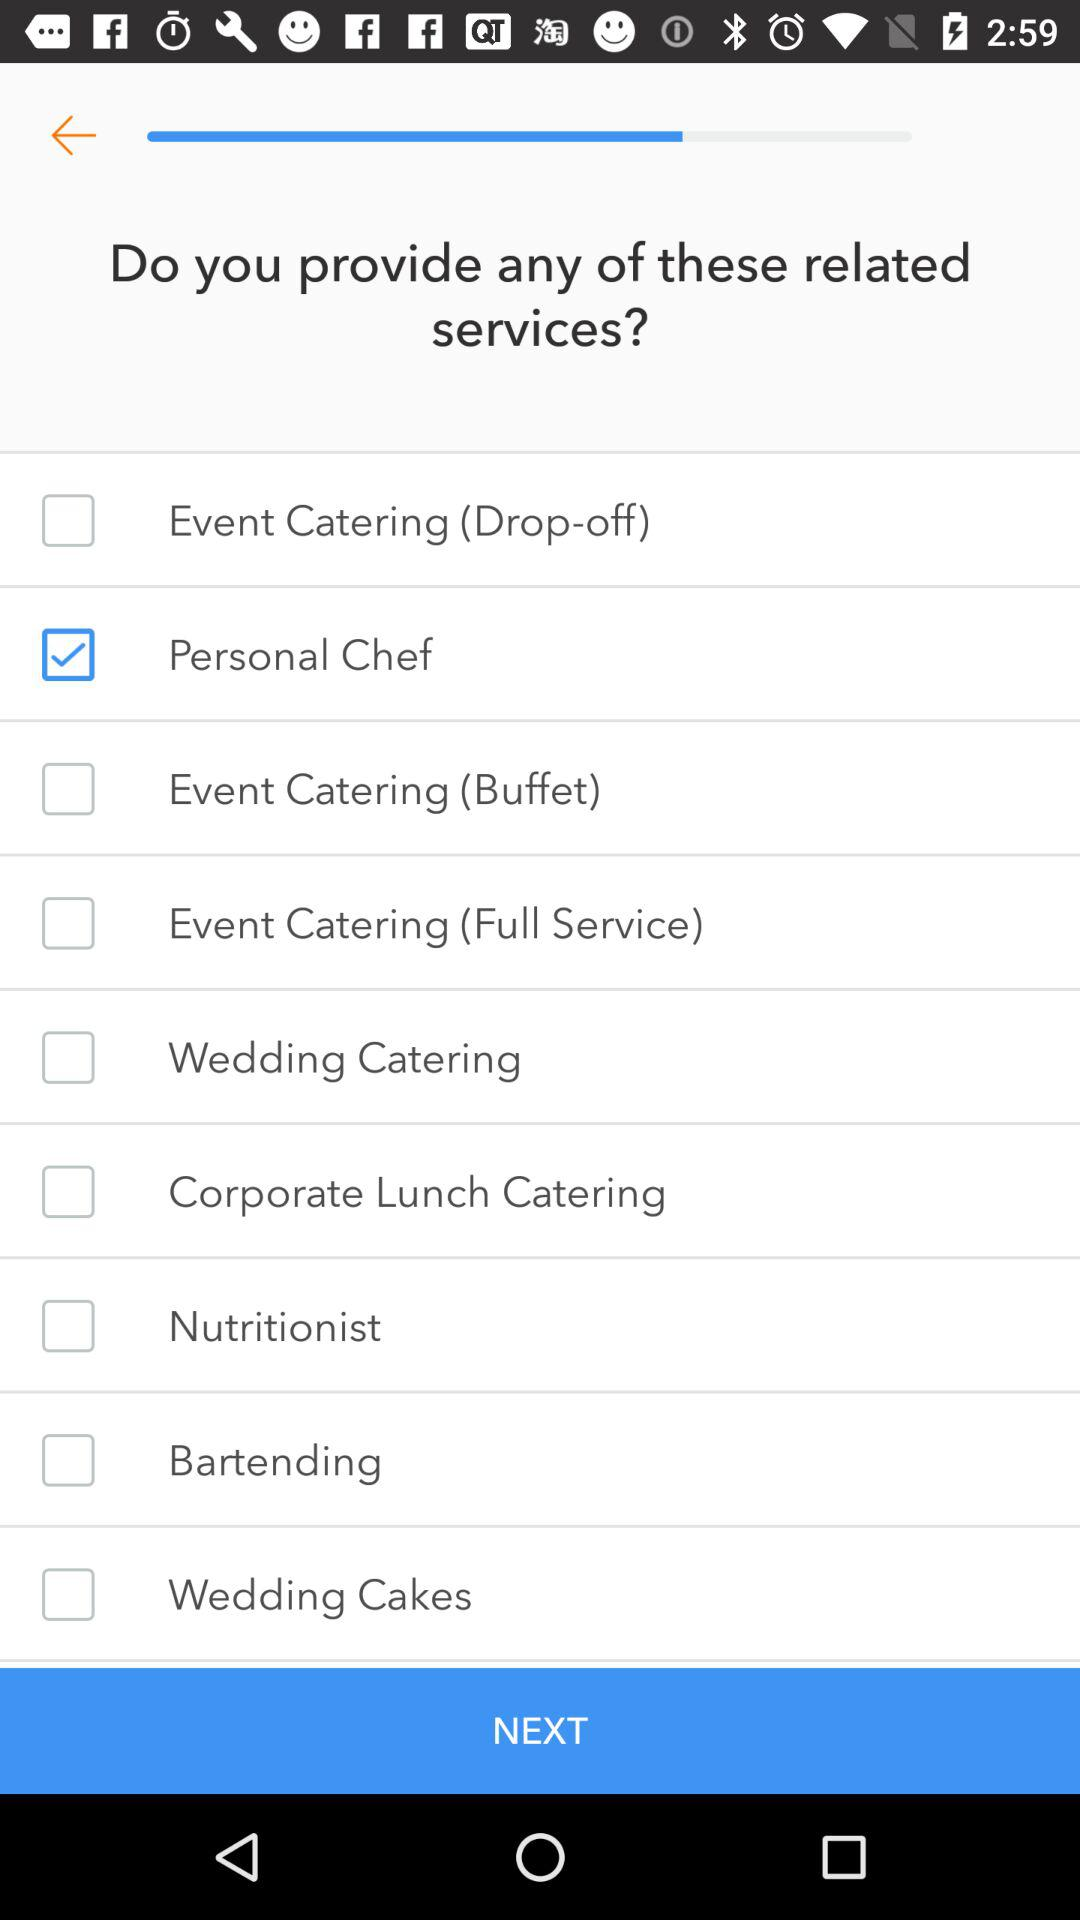What is the status of "Nutritionist"? The status is "off". 